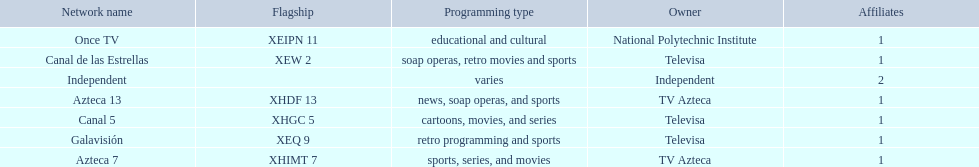Who are the owners of the stations listed here? Televisa, Televisa, TV Azteca, Televisa, National Polytechnic Institute, TV Azteca, Independent. What is the one station owned by national polytechnic institute? Once TV. 